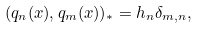Convert formula to latex. <formula><loc_0><loc_0><loc_500><loc_500>( q _ { n } ( x ) , q _ { m } ( x ) ) _ { * } & = h _ { n } \delta _ { m , n } ,</formula> 